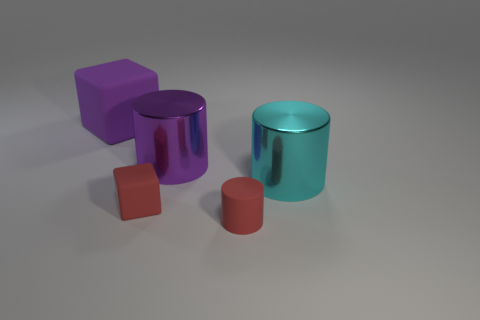Subtract all big cylinders. How many cylinders are left? 1 Add 4 large purple rubber objects. How many objects exist? 9 Subtract all cylinders. How many objects are left? 2 Add 2 gray matte objects. How many gray matte objects exist? 2 Subtract 0 blue blocks. How many objects are left? 5 Subtract all big matte things. Subtract all shiny objects. How many objects are left? 2 Add 3 big rubber things. How many big rubber things are left? 4 